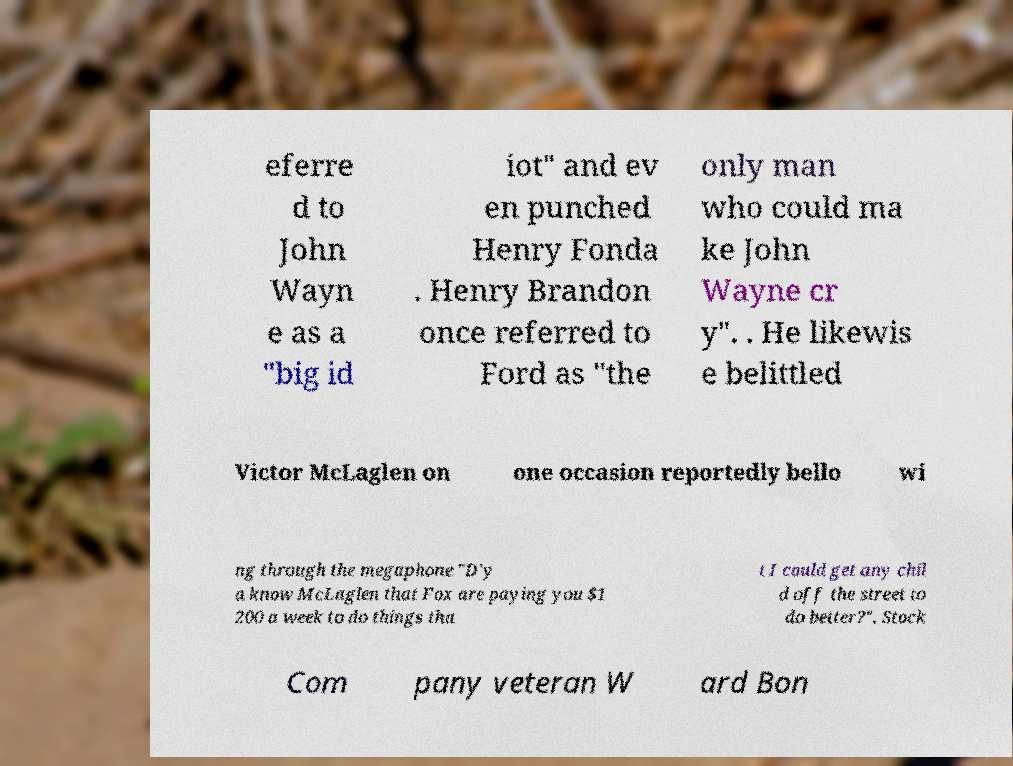Can you read and provide the text displayed in the image?This photo seems to have some interesting text. Can you extract and type it out for me? eferre d to John Wayn e as a "big id iot" and ev en punched Henry Fonda . Henry Brandon once referred to Ford as "the only man who could ma ke John Wayne cr y". . He likewis e belittled Victor McLaglen on one occasion reportedly bello wi ng through the megaphone "D'y a know McLaglen that Fox are paying you $1 200 a week to do things tha t I could get any chil d off the street to do better?". Stock Com pany veteran W ard Bon 